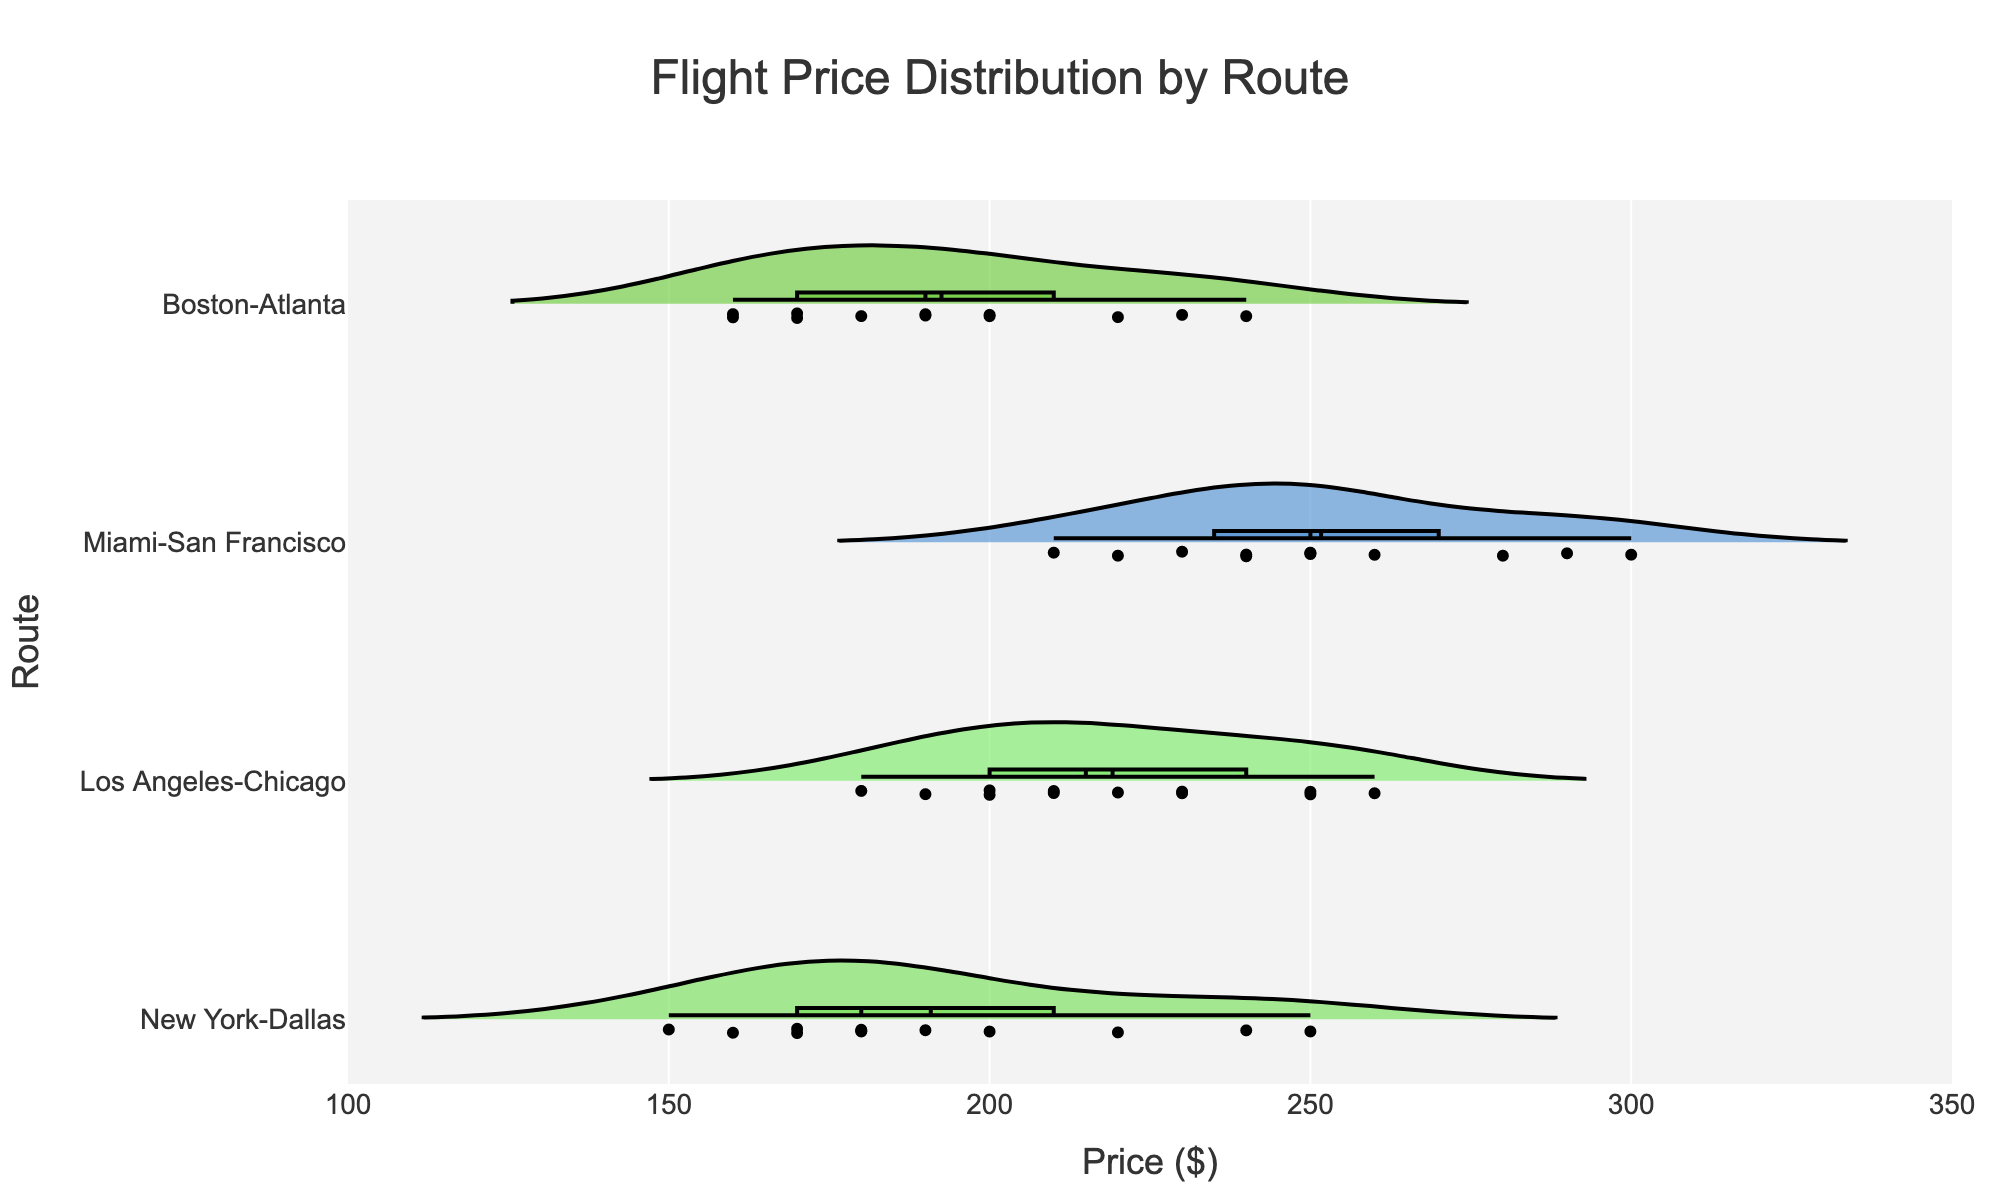What is the title of the figure? The title is usually placed at the top of the chart. It is clearly written.
Answer: Flight Price Distribution by Route What is the average flight price for the Los Angeles-Chicago route? The meanline in the violin plot shows the average price.
Answer: $220 How does the flight price range for Miami-San Francisco compare to Boston-Atlanta? Examine the length of the violins for both routes. Miami-San Francisco has a wider range than Boston-Atlanta.
Answer: Miami-San Francisco has a wider range Which route has the highest median flight price? Identify the median line (inside the box) in each violin plot and compare their vertical positions.
Answer: Miami-San Francisco In which months do flight prices for New York-Dallas reach their peak? Check the highest data points (dots) within the New York-Dallas violin plot.
Answer: July and August Are there more months with flight prices above $200 for Miami-San Francisco or Los Angeles-Chicago? Count the number of data points (dots) above $200 within each respective violin plot.
Answer: Miami-San Francisco Which route has the most consistent (least variable) flight prices? Look for the smallest spread in the violin plots, defined by the horizontal length of the violins.
Answer: Boston-Atlanta What is the approximate flight price range for January for all routes? Locate the January data points (dots with jitter) in each violin plot and estimate their range.
Answer: $150 to $220 How do the average flight prices in January compare across all routes? Look at the meanline (horizontal line within the box) for each route's January data points.
Answer: Miami-San Francisco is the highest; New York-Dallas is the lowest Is the distribution of flight prices for New York-Dallas symmetric or skewed? Examine the shape of the New York-Dallas violin plot. Symmetric violins look balanced.
Answer: Skewed (slightly towards higher prices) 